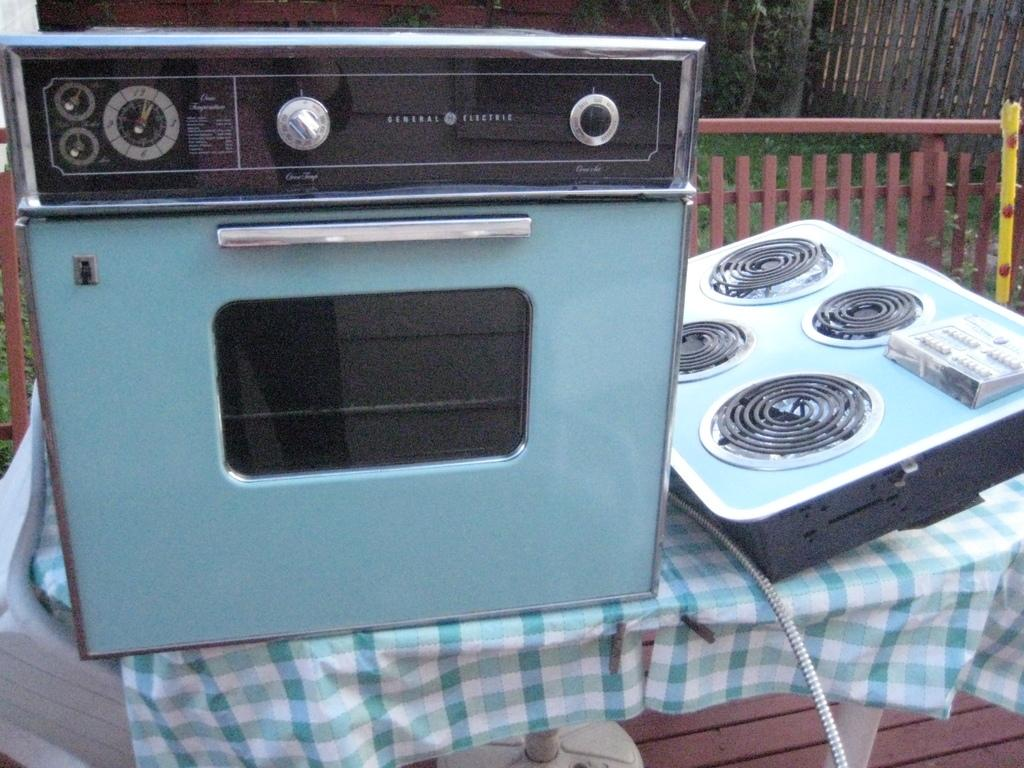Provide a one-sentence caption for the provided image. A General Electric oven is on a table next to a burner element. 